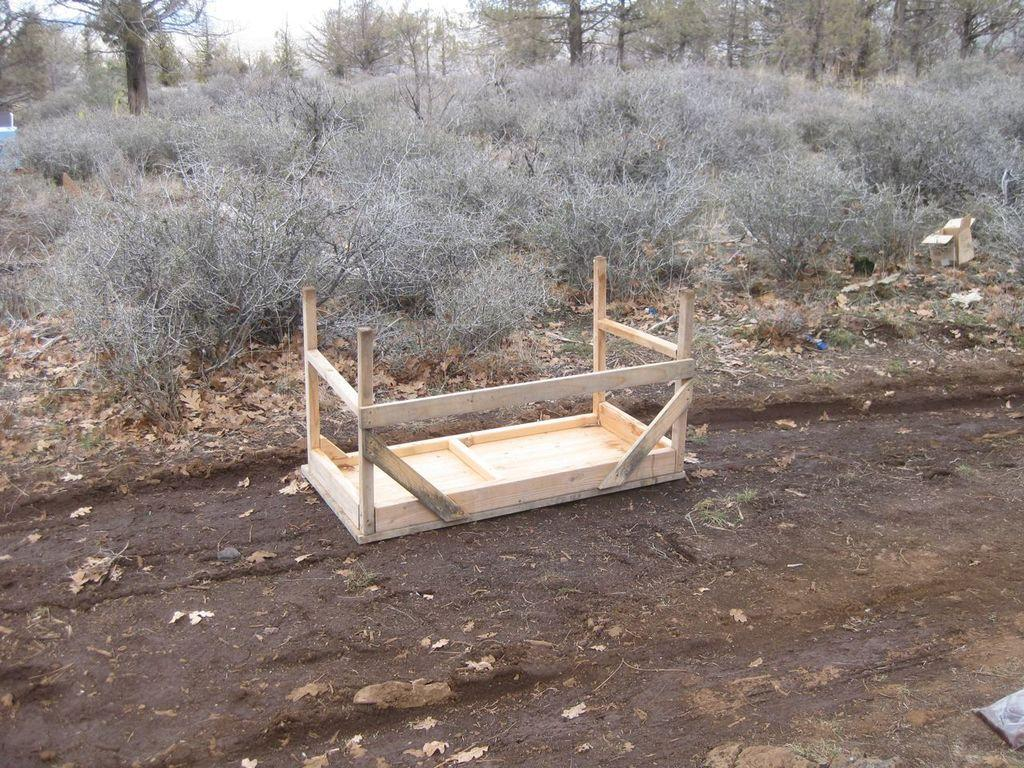What type of plants can be seen in the image? There are many dry plants in the image. What is located behind the dry plants? There are trees behind the dry plants. What type of furniture is present in the image? There is a wooden table in the image. How is the wooden table positioned in the image? The wooden table is thrown on a surface. Where is the wooden table in relation to the dry plants? The surface with the thrown wooden table is in front of the dry plants. What type of lace can be seen on the dry plants in the image? There is no lace present on the dry plants in the image. 